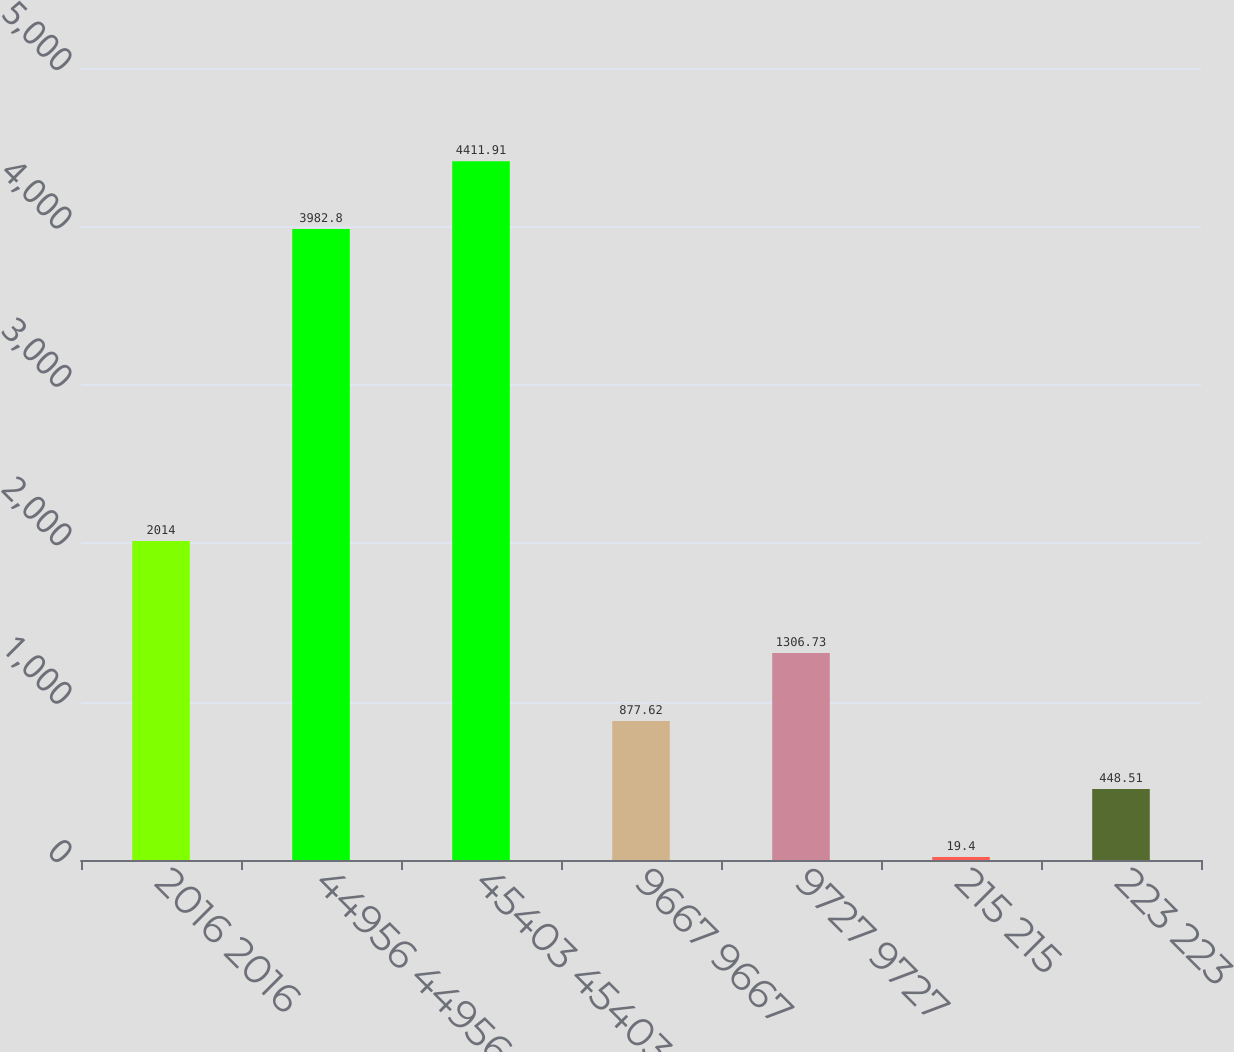Convert chart. <chart><loc_0><loc_0><loc_500><loc_500><bar_chart><fcel>2016 2016<fcel>44956 44956<fcel>45403 45403<fcel>9667 9667<fcel>9727 9727<fcel>215 215<fcel>223 223<nl><fcel>2014<fcel>3982.8<fcel>4411.91<fcel>877.62<fcel>1306.73<fcel>19.4<fcel>448.51<nl></chart> 